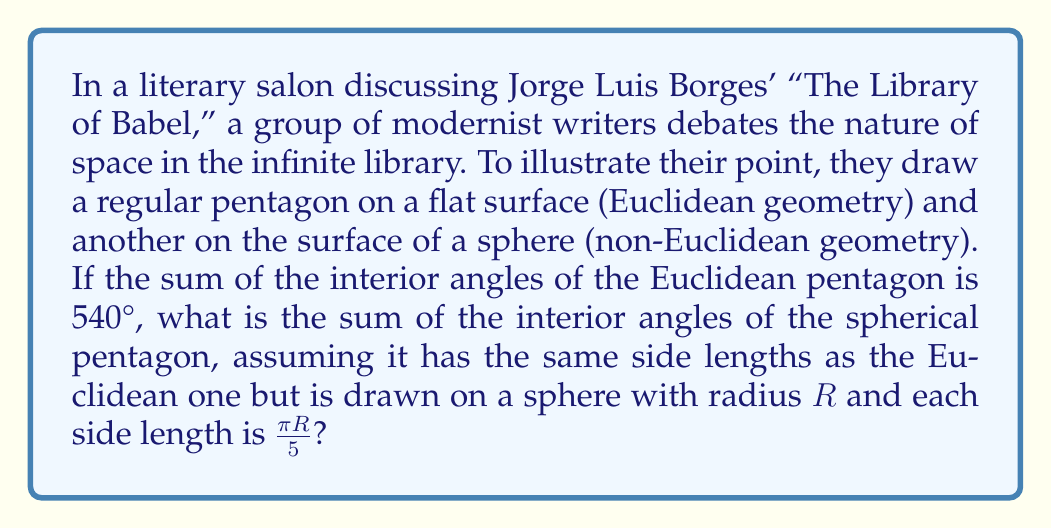Can you solve this math problem? Let's approach this step-by-step:

1) In Euclidean geometry, the sum of interior angles of a pentagon is always 540°. This is given in the question.

2) In spherical geometry (a type of non-Euclidean geometry), the sum of interior angles of a polygon is greater than its Euclidean counterpart. The excess is related to the area of the polygon on the sphere.

3) For a spherical polygon, the sum of interior angles is given by:

   $S = (n-2)\pi + A$

   Where $n$ is the number of sides, and $A$ is the area of the polygon on the sphere.

4) For a pentagon, $n = 5$, so our equation becomes:

   $S = 3\pi + A$

5) Now we need to find the area $A$ of the spherical pentagon. For a regular spherical pentagon with side length $\frac{\pi R}{5}$, the area is given by:

   $A = 5\alpha - 3\pi$

   Where $\alpha$ is the angle at the center of the sphere subtended by one side of the pentagon.

6) To find $\alpha$, we use the formula:

   $\cos(\frac{\alpha}{2}) = \cos(\frac{\pi}{5}) / \sin(\frac{\pi}{5})$

7) Solving this:
   
   $\alpha = 2 \arccos(\cot(\frac{\pi}{5})) \approx 1.8091$ radians

8) Now we can calculate the area:

   $A = 5(1.8091) - 3\pi \approx 0.3062$ steradians

9) Substituting this back into our sum of angles formula:

   $S = 3\pi + 0.3062$

10) Converting to degrees:

    $S = 540° + \frac{0.3062 \times 180°}{\pi} \approx 557.53°$
Answer: $557.53°$ 